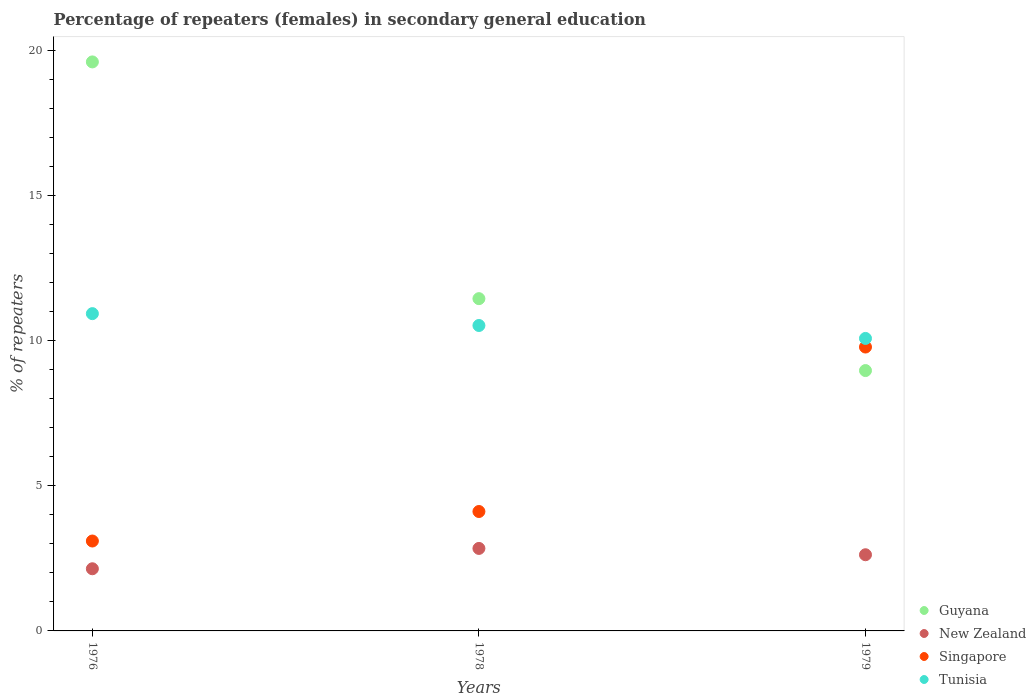How many different coloured dotlines are there?
Offer a terse response. 4. Is the number of dotlines equal to the number of legend labels?
Give a very brief answer. Yes. What is the percentage of female repeaters in New Zealand in 1976?
Your answer should be compact. 2.14. Across all years, what is the maximum percentage of female repeaters in Guyana?
Offer a very short reply. 19.59. Across all years, what is the minimum percentage of female repeaters in Guyana?
Provide a short and direct response. 8.96. In which year was the percentage of female repeaters in Tunisia maximum?
Your response must be concise. 1976. In which year was the percentage of female repeaters in Singapore minimum?
Your response must be concise. 1976. What is the total percentage of female repeaters in Guyana in the graph?
Offer a very short reply. 40. What is the difference between the percentage of female repeaters in Guyana in 1978 and that in 1979?
Your answer should be compact. 2.48. What is the difference between the percentage of female repeaters in New Zealand in 1979 and the percentage of female repeaters in Singapore in 1978?
Offer a very short reply. -1.49. What is the average percentage of female repeaters in New Zealand per year?
Offer a very short reply. 2.53. In the year 1976, what is the difference between the percentage of female repeaters in Guyana and percentage of female repeaters in Singapore?
Make the answer very short. 16.5. What is the ratio of the percentage of female repeaters in Tunisia in 1976 to that in 1979?
Provide a short and direct response. 1.08. Is the percentage of female repeaters in Guyana in 1978 less than that in 1979?
Keep it short and to the point. No. What is the difference between the highest and the second highest percentage of female repeaters in Tunisia?
Keep it short and to the point. 0.41. What is the difference between the highest and the lowest percentage of female repeaters in Guyana?
Keep it short and to the point. 10.63. Is it the case that in every year, the sum of the percentage of female repeaters in Tunisia and percentage of female repeaters in New Zealand  is greater than the percentage of female repeaters in Guyana?
Offer a terse response. No. How many dotlines are there?
Offer a terse response. 4. How many years are there in the graph?
Offer a terse response. 3. Are the values on the major ticks of Y-axis written in scientific E-notation?
Make the answer very short. No. Does the graph contain any zero values?
Make the answer very short. No. Does the graph contain grids?
Ensure brevity in your answer.  No. Where does the legend appear in the graph?
Make the answer very short. Bottom right. How many legend labels are there?
Offer a very short reply. 4. What is the title of the graph?
Offer a terse response. Percentage of repeaters (females) in secondary general education. What is the label or title of the X-axis?
Your answer should be very brief. Years. What is the label or title of the Y-axis?
Ensure brevity in your answer.  % of repeaters. What is the % of repeaters of Guyana in 1976?
Provide a succinct answer. 19.59. What is the % of repeaters of New Zealand in 1976?
Give a very brief answer. 2.14. What is the % of repeaters in Singapore in 1976?
Provide a succinct answer. 3.1. What is the % of repeaters in Tunisia in 1976?
Give a very brief answer. 10.92. What is the % of repeaters in Guyana in 1978?
Offer a very short reply. 11.44. What is the % of repeaters in New Zealand in 1978?
Ensure brevity in your answer.  2.84. What is the % of repeaters of Singapore in 1978?
Give a very brief answer. 4.11. What is the % of repeaters in Tunisia in 1978?
Keep it short and to the point. 10.52. What is the % of repeaters in Guyana in 1979?
Provide a short and direct response. 8.96. What is the % of repeaters in New Zealand in 1979?
Keep it short and to the point. 2.62. What is the % of repeaters of Singapore in 1979?
Provide a succinct answer. 9.77. What is the % of repeaters in Tunisia in 1979?
Give a very brief answer. 10.07. Across all years, what is the maximum % of repeaters in Guyana?
Give a very brief answer. 19.59. Across all years, what is the maximum % of repeaters of New Zealand?
Make the answer very short. 2.84. Across all years, what is the maximum % of repeaters in Singapore?
Provide a short and direct response. 9.77. Across all years, what is the maximum % of repeaters of Tunisia?
Make the answer very short. 10.92. Across all years, what is the minimum % of repeaters of Guyana?
Offer a terse response. 8.96. Across all years, what is the minimum % of repeaters of New Zealand?
Your answer should be compact. 2.14. Across all years, what is the minimum % of repeaters of Singapore?
Provide a short and direct response. 3.1. Across all years, what is the minimum % of repeaters of Tunisia?
Keep it short and to the point. 10.07. What is the total % of repeaters in Guyana in the graph?
Offer a very short reply. 40. What is the total % of repeaters in New Zealand in the graph?
Provide a succinct answer. 7.6. What is the total % of repeaters of Singapore in the graph?
Provide a succinct answer. 16.98. What is the total % of repeaters of Tunisia in the graph?
Provide a short and direct response. 31.51. What is the difference between the % of repeaters of Guyana in 1976 and that in 1978?
Make the answer very short. 8.15. What is the difference between the % of repeaters in New Zealand in 1976 and that in 1978?
Your response must be concise. -0.7. What is the difference between the % of repeaters of Singapore in 1976 and that in 1978?
Ensure brevity in your answer.  -1.02. What is the difference between the % of repeaters of Tunisia in 1976 and that in 1978?
Keep it short and to the point. 0.41. What is the difference between the % of repeaters in Guyana in 1976 and that in 1979?
Make the answer very short. 10.63. What is the difference between the % of repeaters of New Zealand in 1976 and that in 1979?
Provide a succinct answer. -0.48. What is the difference between the % of repeaters in Singapore in 1976 and that in 1979?
Offer a terse response. -6.68. What is the difference between the % of repeaters of Tunisia in 1976 and that in 1979?
Ensure brevity in your answer.  0.85. What is the difference between the % of repeaters of Guyana in 1978 and that in 1979?
Make the answer very short. 2.48. What is the difference between the % of repeaters in New Zealand in 1978 and that in 1979?
Your answer should be compact. 0.22. What is the difference between the % of repeaters of Singapore in 1978 and that in 1979?
Your answer should be very brief. -5.66. What is the difference between the % of repeaters in Tunisia in 1978 and that in 1979?
Your response must be concise. 0.45. What is the difference between the % of repeaters of Guyana in 1976 and the % of repeaters of New Zealand in 1978?
Keep it short and to the point. 16.75. What is the difference between the % of repeaters of Guyana in 1976 and the % of repeaters of Singapore in 1978?
Provide a short and direct response. 15.48. What is the difference between the % of repeaters of Guyana in 1976 and the % of repeaters of Tunisia in 1978?
Ensure brevity in your answer.  9.08. What is the difference between the % of repeaters in New Zealand in 1976 and the % of repeaters in Singapore in 1978?
Provide a succinct answer. -1.97. What is the difference between the % of repeaters in New Zealand in 1976 and the % of repeaters in Tunisia in 1978?
Your answer should be very brief. -8.38. What is the difference between the % of repeaters in Singapore in 1976 and the % of repeaters in Tunisia in 1978?
Your response must be concise. -7.42. What is the difference between the % of repeaters of Guyana in 1976 and the % of repeaters of New Zealand in 1979?
Make the answer very short. 16.97. What is the difference between the % of repeaters of Guyana in 1976 and the % of repeaters of Singapore in 1979?
Provide a short and direct response. 9.82. What is the difference between the % of repeaters of Guyana in 1976 and the % of repeaters of Tunisia in 1979?
Give a very brief answer. 9.52. What is the difference between the % of repeaters of New Zealand in 1976 and the % of repeaters of Singapore in 1979?
Provide a short and direct response. -7.63. What is the difference between the % of repeaters of New Zealand in 1976 and the % of repeaters of Tunisia in 1979?
Keep it short and to the point. -7.93. What is the difference between the % of repeaters in Singapore in 1976 and the % of repeaters in Tunisia in 1979?
Your answer should be very brief. -6.98. What is the difference between the % of repeaters in Guyana in 1978 and the % of repeaters in New Zealand in 1979?
Ensure brevity in your answer.  8.82. What is the difference between the % of repeaters of Guyana in 1978 and the % of repeaters of Singapore in 1979?
Your answer should be compact. 1.67. What is the difference between the % of repeaters of Guyana in 1978 and the % of repeaters of Tunisia in 1979?
Give a very brief answer. 1.37. What is the difference between the % of repeaters in New Zealand in 1978 and the % of repeaters in Singapore in 1979?
Make the answer very short. -6.93. What is the difference between the % of repeaters in New Zealand in 1978 and the % of repeaters in Tunisia in 1979?
Your response must be concise. -7.23. What is the difference between the % of repeaters of Singapore in 1978 and the % of repeaters of Tunisia in 1979?
Your answer should be compact. -5.96. What is the average % of repeaters of Guyana per year?
Provide a short and direct response. 13.33. What is the average % of repeaters in New Zealand per year?
Offer a terse response. 2.53. What is the average % of repeaters in Singapore per year?
Ensure brevity in your answer.  5.66. What is the average % of repeaters of Tunisia per year?
Make the answer very short. 10.5. In the year 1976, what is the difference between the % of repeaters of Guyana and % of repeaters of New Zealand?
Make the answer very short. 17.45. In the year 1976, what is the difference between the % of repeaters in Guyana and % of repeaters in Singapore?
Offer a very short reply. 16.5. In the year 1976, what is the difference between the % of repeaters of Guyana and % of repeaters of Tunisia?
Your answer should be very brief. 8.67. In the year 1976, what is the difference between the % of repeaters of New Zealand and % of repeaters of Singapore?
Provide a succinct answer. -0.96. In the year 1976, what is the difference between the % of repeaters in New Zealand and % of repeaters in Tunisia?
Your response must be concise. -8.78. In the year 1976, what is the difference between the % of repeaters of Singapore and % of repeaters of Tunisia?
Give a very brief answer. -7.83. In the year 1978, what is the difference between the % of repeaters of Guyana and % of repeaters of New Zealand?
Your response must be concise. 8.6. In the year 1978, what is the difference between the % of repeaters of Guyana and % of repeaters of Singapore?
Provide a short and direct response. 7.33. In the year 1978, what is the difference between the % of repeaters in Guyana and % of repeaters in Tunisia?
Your answer should be very brief. 0.92. In the year 1978, what is the difference between the % of repeaters in New Zealand and % of repeaters in Singapore?
Make the answer very short. -1.27. In the year 1978, what is the difference between the % of repeaters in New Zealand and % of repeaters in Tunisia?
Your answer should be compact. -7.68. In the year 1978, what is the difference between the % of repeaters in Singapore and % of repeaters in Tunisia?
Make the answer very short. -6.4. In the year 1979, what is the difference between the % of repeaters in Guyana and % of repeaters in New Zealand?
Keep it short and to the point. 6.34. In the year 1979, what is the difference between the % of repeaters in Guyana and % of repeaters in Singapore?
Your answer should be very brief. -0.81. In the year 1979, what is the difference between the % of repeaters in Guyana and % of repeaters in Tunisia?
Make the answer very short. -1.11. In the year 1979, what is the difference between the % of repeaters in New Zealand and % of repeaters in Singapore?
Keep it short and to the point. -7.15. In the year 1979, what is the difference between the % of repeaters of New Zealand and % of repeaters of Tunisia?
Offer a terse response. -7.45. In the year 1979, what is the difference between the % of repeaters in Singapore and % of repeaters in Tunisia?
Give a very brief answer. -0.3. What is the ratio of the % of repeaters of Guyana in 1976 to that in 1978?
Offer a very short reply. 1.71. What is the ratio of the % of repeaters of New Zealand in 1976 to that in 1978?
Ensure brevity in your answer.  0.75. What is the ratio of the % of repeaters of Singapore in 1976 to that in 1978?
Your answer should be very brief. 0.75. What is the ratio of the % of repeaters in Tunisia in 1976 to that in 1978?
Provide a short and direct response. 1.04. What is the ratio of the % of repeaters of Guyana in 1976 to that in 1979?
Provide a short and direct response. 2.19. What is the ratio of the % of repeaters in New Zealand in 1976 to that in 1979?
Give a very brief answer. 0.82. What is the ratio of the % of repeaters of Singapore in 1976 to that in 1979?
Your answer should be compact. 0.32. What is the ratio of the % of repeaters in Tunisia in 1976 to that in 1979?
Offer a terse response. 1.08. What is the ratio of the % of repeaters in Guyana in 1978 to that in 1979?
Your answer should be very brief. 1.28. What is the ratio of the % of repeaters in New Zealand in 1978 to that in 1979?
Your answer should be very brief. 1.08. What is the ratio of the % of repeaters in Singapore in 1978 to that in 1979?
Your answer should be compact. 0.42. What is the ratio of the % of repeaters in Tunisia in 1978 to that in 1979?
Ensure brevity in your answer.  1.04. What is the difference between the highest and the second highest % of repeaters in Guyana?
Your response must be concise. 8.15. What is the difference between the highest and the second highest % of repeaters of New Zealand?
Your answer should be very brief. 0.22. What is the difference between the highest and the second highest % of repeaters of Singapore?
Offer a very short reply. 5.66. What is the difference between the highest and the second highest % of repeaters in Tunisia?
Ensure brevity in your answer.  0.41. What is the difference between the highest and the lowest % of repeaters of Guyana?
Your answer should be very brief. 10.63. What is the difference between the highest and the lowest % of repeaters in New Zealand?
Keep it short and to the point. 0.7. What is the difference between the highest and the lowest % of repeaters in Singapore?
Your answer should be compact. 6.68. What is the difference between the highest and the lowest % of repeaters in Tunisia?
Keep it short and to the point. 0.85. 